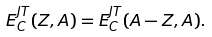<formula> <loc_0><loc_0><loc_500><loc_500>E _ { C } ^ { J T } ( Z , A ) = E _ { C } ^ { J T } ( A - Z , A ) .</formula> 